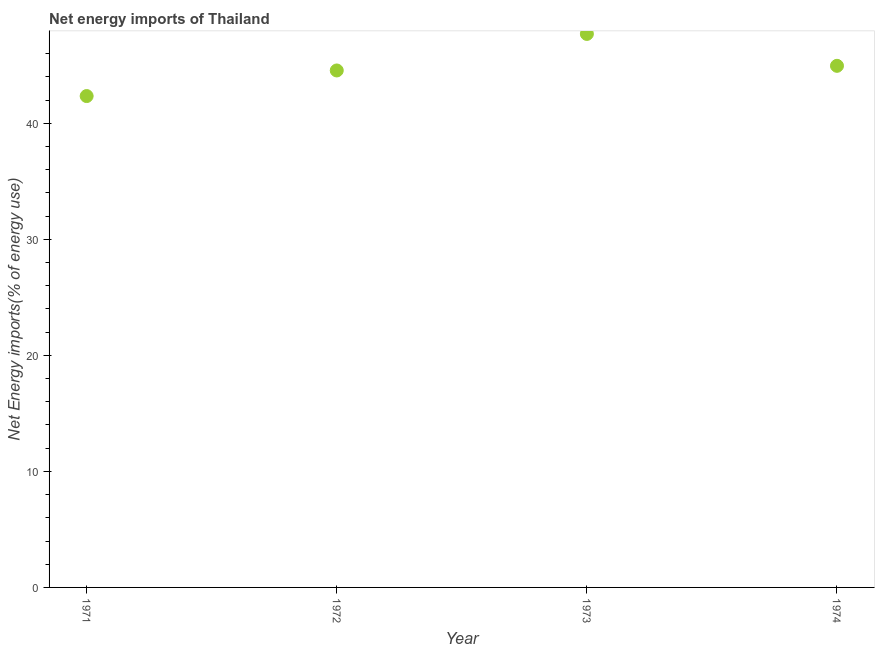What is the energy imports in 1972?
Make the answer very short. 44.55. Across all years, what is the maximum energy imports?
Keep it short and to the point. 47.7. Across all years, what is the minimum energy imports?
Provide a succinct answer. 42.34. In which year was the energy imports minimum?
Offer a very short reply. 1971. What is the sum of the energy imports?
Provide a succinct answer. 179.54. What is the difference between the energy imports in 1972 and 1974?
Provide a short and direct response. -0.4. What is the average energy imports per year?
Offer a terse response. 44.88. What is the median energy imports?
Offer a terse response. 44.75. In how many years, is the energy imports greater than 40 %?
Your response must be concise. 4. What is the ratio of the energy imports in 1971 to that in 1974?
Offer a terse response. 0.94. What is the difference between the highest and the second highest energy imports?
Your response must be concise. 2.75. Is the sum of the energy imports in 1973 and 1974 greater than the maximum energy imports across all years?
Your response must be concise. Yes. What is the difference between the highest and the lowest energy imports?
Your answer should be compact. 5.35. In how many years, is the energy imports greater than the average energy imports taken over all years?
Your response must be concise. 2. Does the energy imports monotonically increase over the years?
Make the answer very short. No. How many dotlines are there?
Ensure brevity in your answer.  1. How many years are there in the graph?
Offer a very short reply. 4. Are the values on the major ticks of Y-axis written in scientific E-notation?
Your answer should be very brief. No. Does the graph contain any zero values?
Keep it short and to the point. No. Does the graph contain grids?
Your answer should be very brief. No. What is the title of the graph?
Give a very brief answer. Net energy imports of Thailand. What is the label or title of the X-axis?
Make the answer very short. Year. What is the label or title of the Y-axis?
Your answer should be compact. Net Energy imports(% of energy use). What is the Net Energy imports(% of energy use) in 1971?
Your answer should be compact. 42.34. What is the Net Energy imports(% of energy use) in 1972?
Provide a short and direct response. 44.55. What is the Net Energy imports(% of energy use) in 1973?
Make the answer very short. 47.7. What is the Net Energy imports(% of energy use) in 1974?
Provide a succinct answer. 44.95. What is the difference between the Net Energy imports(% of energy use) in 1971 and 1972?
Offer a very short reply. -2.21. What is the difference between the Net Energy imports(% of energy use) in 1971 and 1973?
Provide a short and direct response. -5.35. What is the difference between the Net Energy imports(% of energy use) in 1971 and 1974?
Provide a short and direct response. -2.61. What is the difference between the Net Energy imports(% of energy use) in 1972 and 1973?
Keep it short and to the point. -3.15. What is the difference between the Net Energy imports(% of energy use) in 1972 and 1974?
Make the answer very short. -0.4. What is the difference between the Net Energy imports(% of energy use) in 1973 and 1974?
Ensure brevity in your answer.  2.75. What is the ratio of the Net Energy imports(% of energy use) in 1971 to that in 1972?
Provide a succinct answer. 0.95. What is the ratio of the Net Energy imports(% of energy use) in 1971 to that in 1973?
Your answer should be compact. 0.89. What is the ratio of the Net Energy imports(% of energy use) in 1971 to that in 1974?
Your response must be concise. 0.94. What is the ratio of the Net Energy imports(% of energy use) in 1972 to that in 1973?
Make the answer very short. 0.93. What is the ratio of the Net Energy imports(% of energy use) in 1972 to that in 1974?
Provide a succinct answer. 0.99. What is the ratio of the Net Energy imports(% of energy use) in 1973 to that in 1974?
Provide a succinct answer. 1.06. 